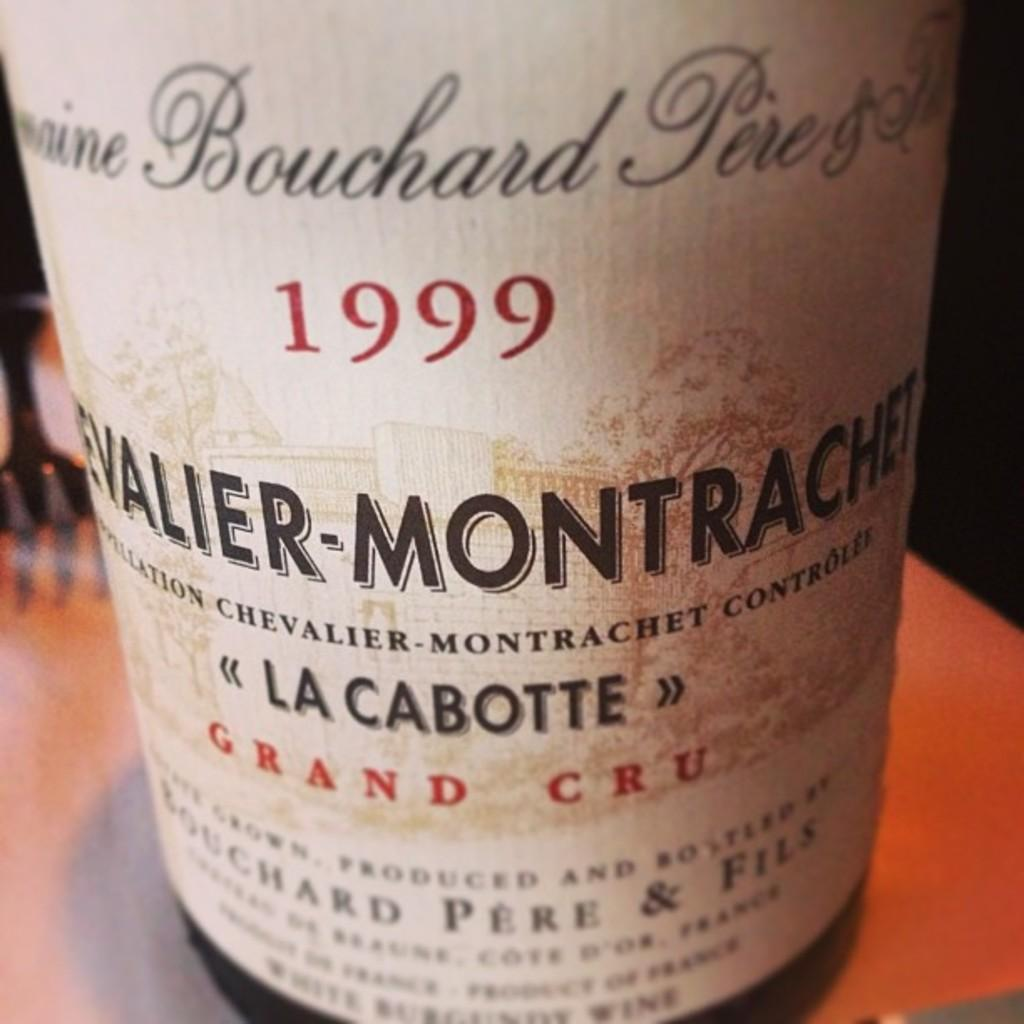<image>
Present a compact description of the photo's key features. A bottle of wine from 1999 from La Cabotte. 